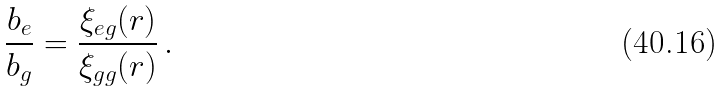Convert formula to latex. <formula><loc_0><loc_0><loc_500><loc_500>\frac { b _ { e } } { b _ { g } } = \frac { \xi _ { e g } ( r ) } { \xi _ { g g } ( r ) } \, .</formula> 